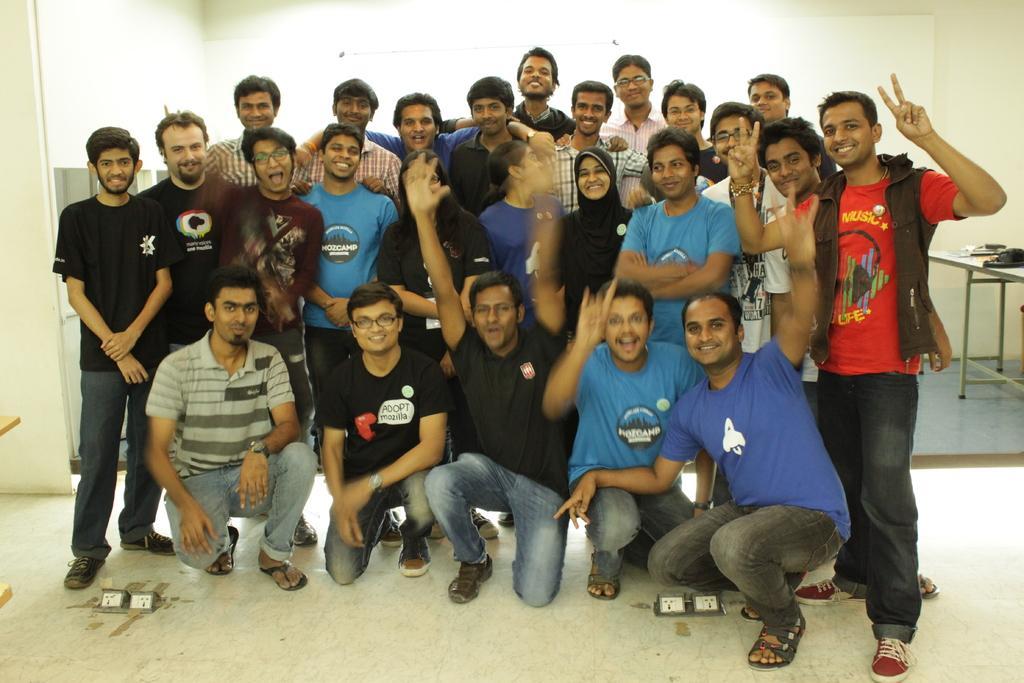Can you describe this image briefly? In this picture there are group of people those who are standing in the center of the image, there are bags on the bench in the background area of the image. 